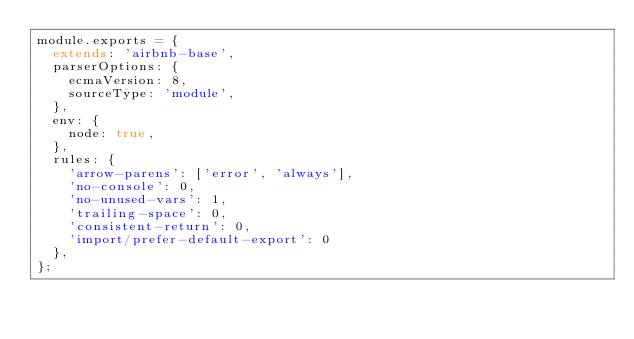Convert code to text. <code><loc_0><loc_0><loc_500><loc_500><_JavaScript_>module.exports = {
  extends: 'airbnb-base',
  parserOptions: {
    ecmaVersion: 8,
    sourceType: 'module',
  },
  env: {
    node: true,
  },
  rules: {
    'arrow-parens': ['error', 'always'],
    'no-console': 0,
    'no-unused-vars': 1,
    'trailing-space': 0,
    'consistent-return': 0,
    'import/prefer-default-export': 0
  },
};
</code> 